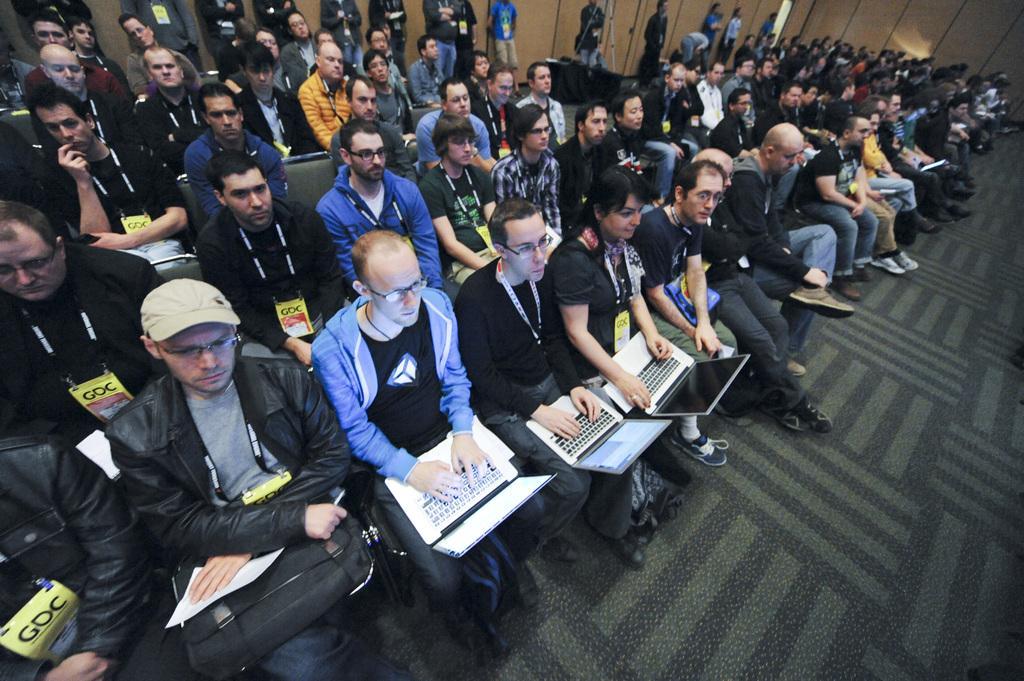How would you summarize this image in a sentence or two? In the picture I can see these three persons are holding laptops in their hands and sitting on the chairs and these people are also sitting on the chairs. In the background, I can see these people are standing near the wall. 